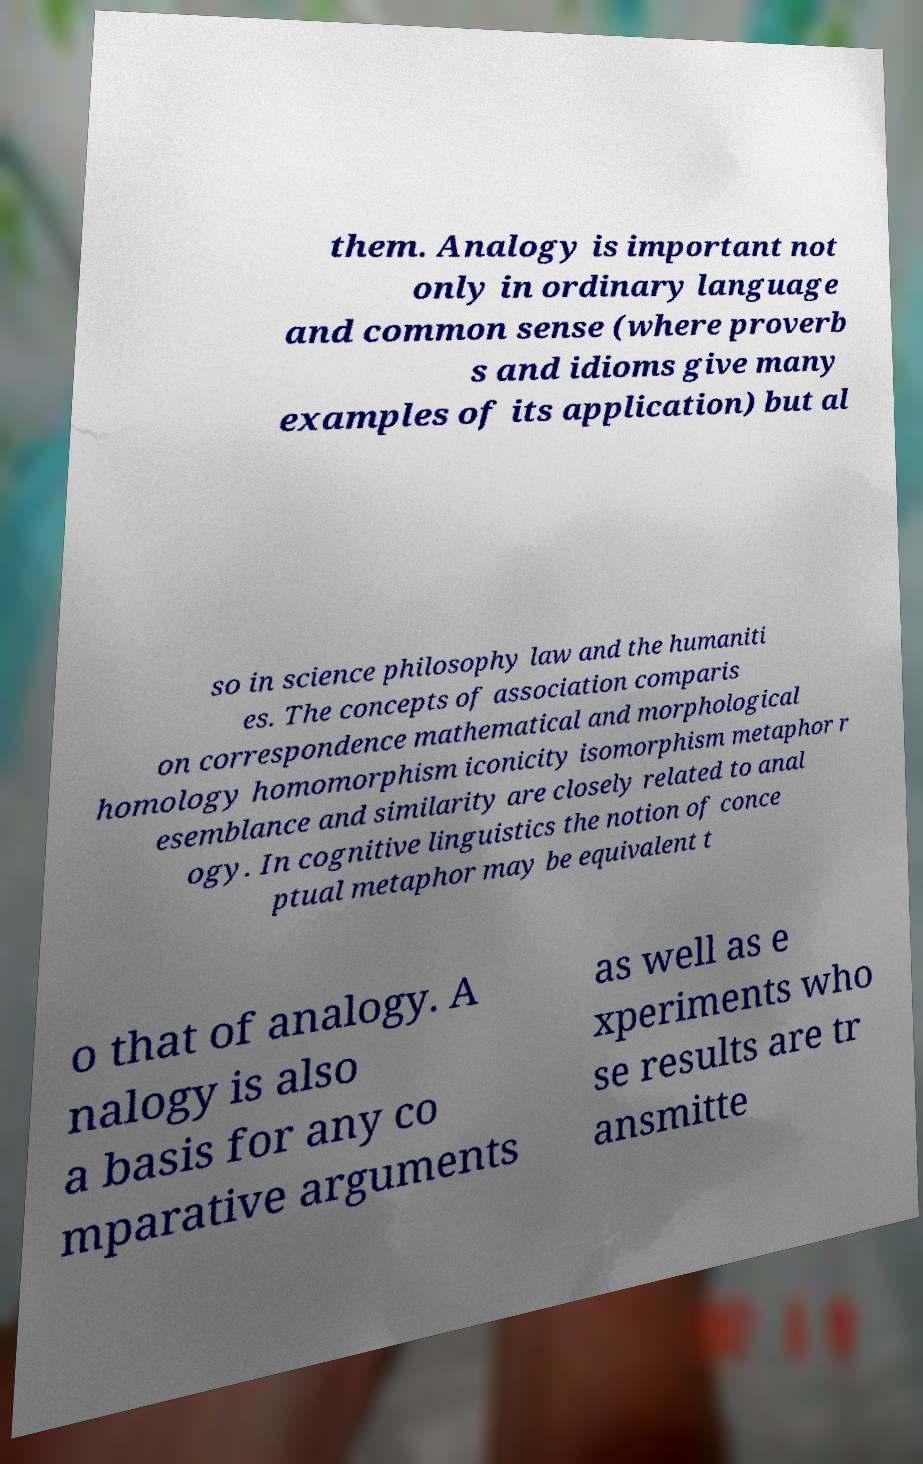Please read and relay the text visible in this image. What does it say? them. Analogy is important not only in ordinary language and common sense (where proverb s and idioms give many examples of its application) but al so in science philosophy law and the humaniti es. The concepts of association comparis on correspondence mathematical and morphological homology homomorphism iconicity isomorphism metaphor r esemblance and similarity are closely related to anal ogy. In cognitive linguistics the notion of conce ptual metaphor may be equivalent t o that of analogy. A nalogy is also a basis for any co mparative arguments as well as e xperiments who se results are tr ansmitte 